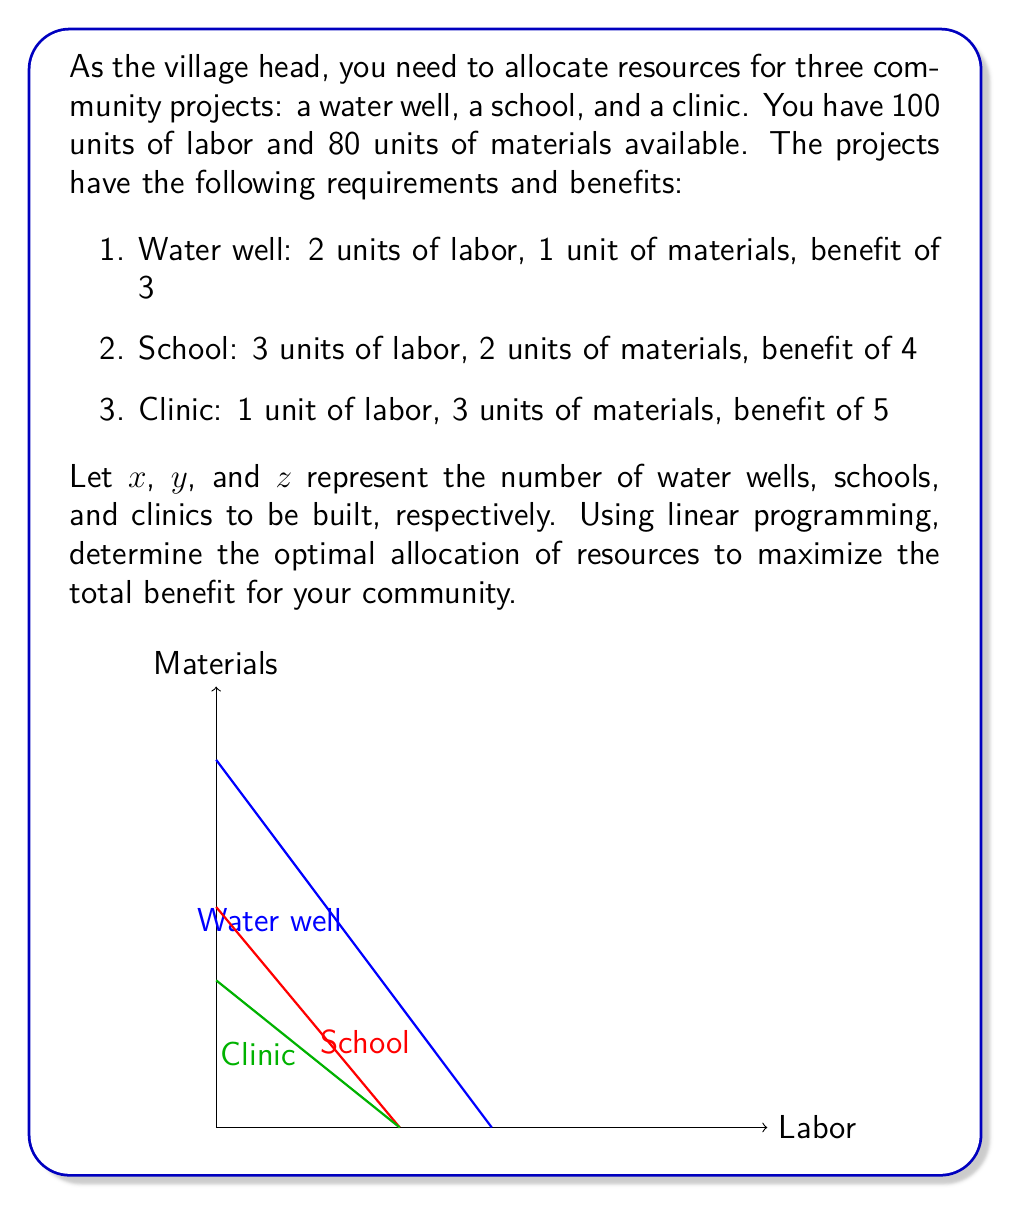What is the answer to this math problem? To solve this linear programming problem, we'll follow these steps:

1. Define the objective function
2. List the constraints
3. Set up the linear programming problem
4. Solve using the simplex method or graphical method

Step 1: Define the objective function
The objective is to maximize the total benefit:
$$\text{Maximize } Z = 3x + 4y + 5z$$

Step 2: List the constraints
Labor constraint: $2x + 3y + z \leq 100$
Materials constraint: $x + 2y + 3z \leq 80$
Non-negativity constraints: $x \geq 0, y \geq 0, z \geq 0$

Step 3: Set up the linear programming problem
$$\begin{align*}
\text{Maximize } & Z = 3x + 4y + 5z \\
\text{Subject to: } & 2x + 3y + z \leq 100 \\
& x + 2y + 3z \leq 80 \\
& x, y, z \geq 0
\end{align*}$$

Step 4: Solve using the simplex method
We'll use the simplex method to solve this problem. After introducing slack variables and performing iterations, we arrive at the optimal solution:

$$\begin{align*}
x &= 20 \text{ (water wells)} \\
y &= 20 \text{ (schools)} \\
z &= 0 \text{ (clinics)}
\end{align*}$$

The maximum benefit achieved is:
$$Z = 3(20) + 4(20) + 5(0) = 140$$

To verify the solution:
Labor used: $2(20) + 3(20) + 1(0) = 100$ (matches constraint)
Materials used: $1(20) + 2(20) + 3(0) = 60$ (within constraint)

This solution suggests building 20 water wells and 20 schools to maximize the benefit for the community while staying within the resource constraints.
Answer: 20 water wells, 20 schools, 0 clinics; Maximum benefit: 140 